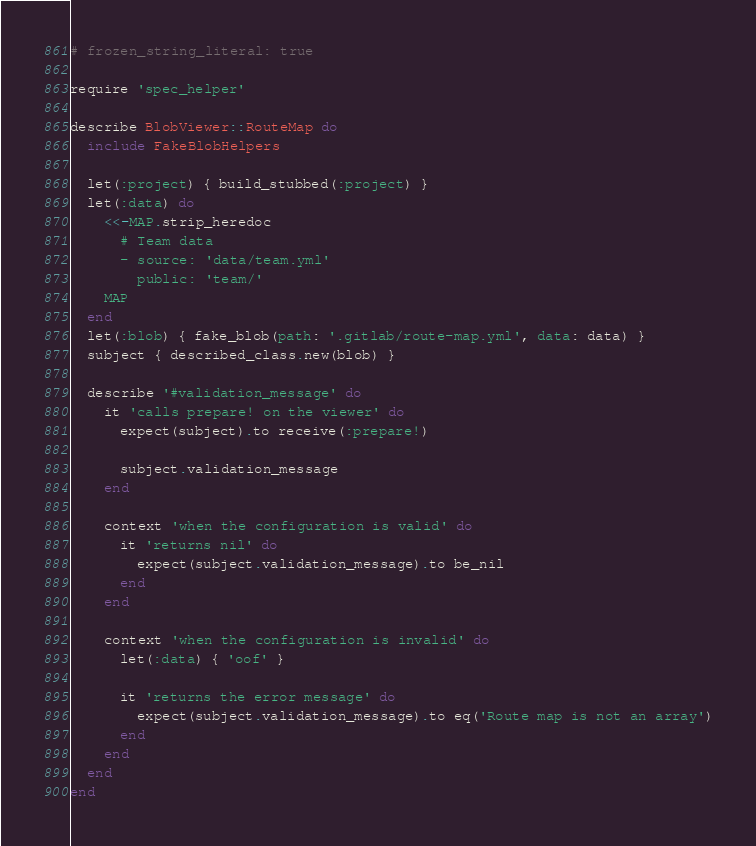Convert code to text. <code><loc_0><loc_0><loc_500><loc_500><_Ruby_># frozen_string_literal: true

require 'spec_helper'

describe BlobViewer::RouteMap do
  include FakeBlobHelpers

  let(:project) { build_stubbed(:project) }
  let(:data) do
    <<-MAP.strip_heredoc
      # Team data
      - source: 'data/team.yml'
        public: 'team/'
    MAP
  end
  let(:blob) { fake_blob(path: '.gitlab/route-map.yml', data: data) }
  subject { described_class.new(blob) }

  describe '#validation_message' do
    it 'calls prepare! on the viewer' do
      expect(subject).to receive(:prepare!)

      subject.validation_message
    end

    context 'when the configuration is valid' do
      it 'returns nil' do
        expect(subject.validation_message).to be_nil
      end
    end

    context 'when the configuration is invalid' do
      let(:data) { 'oof' }

      it 'returns the error message' do
        expect(subject.validation_message).to eq('Route map is not an array')
      end
    end
  end
end
</code> 